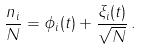Convert formula to latex. <formula><loc_0><loc_0><loc_500><loc_500>\frac { n _ { i } } { N } = \phi _ { i } ( t ) + \frac { \xi _ { i } ( t ) } { \sqrt { N } } \, .</formula> 